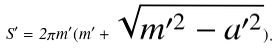<formula> <loc_0><loc_0><loc_500><loc_500>S ^ { \prime } = 2 \pi m ^ { \prime } ( m ^ { \prime } + \sqrt { m ^ { \prime 2 } - a ^ { \prime 2 } } ) .</formula> 